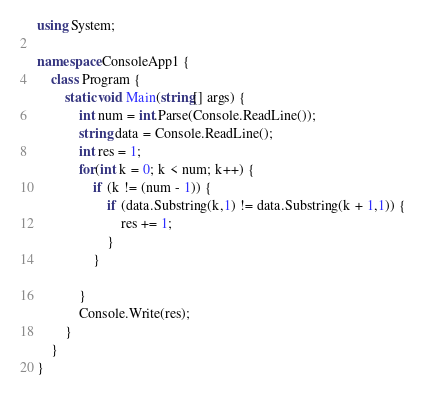Convert code to text. <code><loc_0><loc_0><loc_500><loc_500><_C#_>using System;

namespace ConsoleApp1 {
    class Program {
        static void Main(string[] args) {
            int num = int.Parse(Console.ReadLine());
            string data = Console.ReadLine();
            int res = 1;
            for(int k = 0; k < num; k++) {
                if (k != (num - 1)) {
                    if (data.Substring(k,1) != data.Substring(k + 1,1)) {
                        res += 1;
                    }
                }
          
            }
            Console.Write(res);
        }
    }
}
</code> 